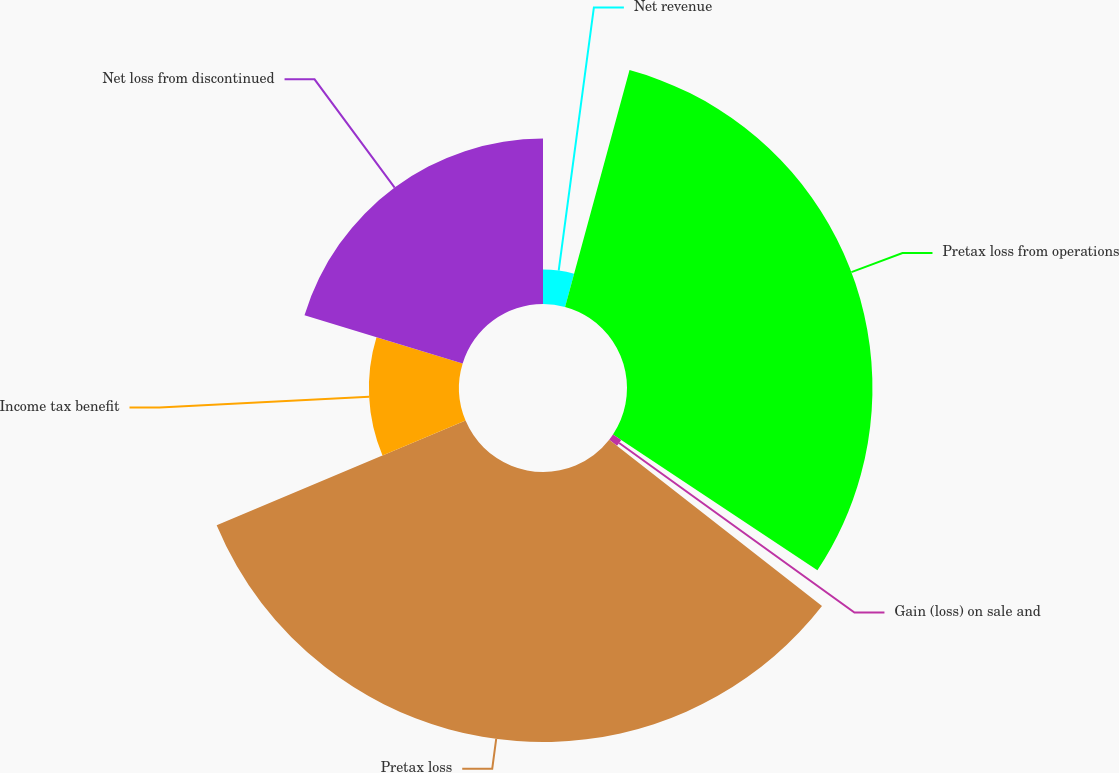Convert chart. <chart><loc_0><loc_0><loc_500><loc_500><pie_chart><fcel>Net revenue<fcel>Pretax loss from operations<fcel>Gain (loss) on sale and<fcel>Pretax loss<fcel>Income tax benefit<fcel>Net loss from discontinued<nl><fcel>4.23%<fcel>30.1%<fcel>1.22%<fcel>33.11%<fcel>11.05%<fcel>20.28%<nl></chart> 